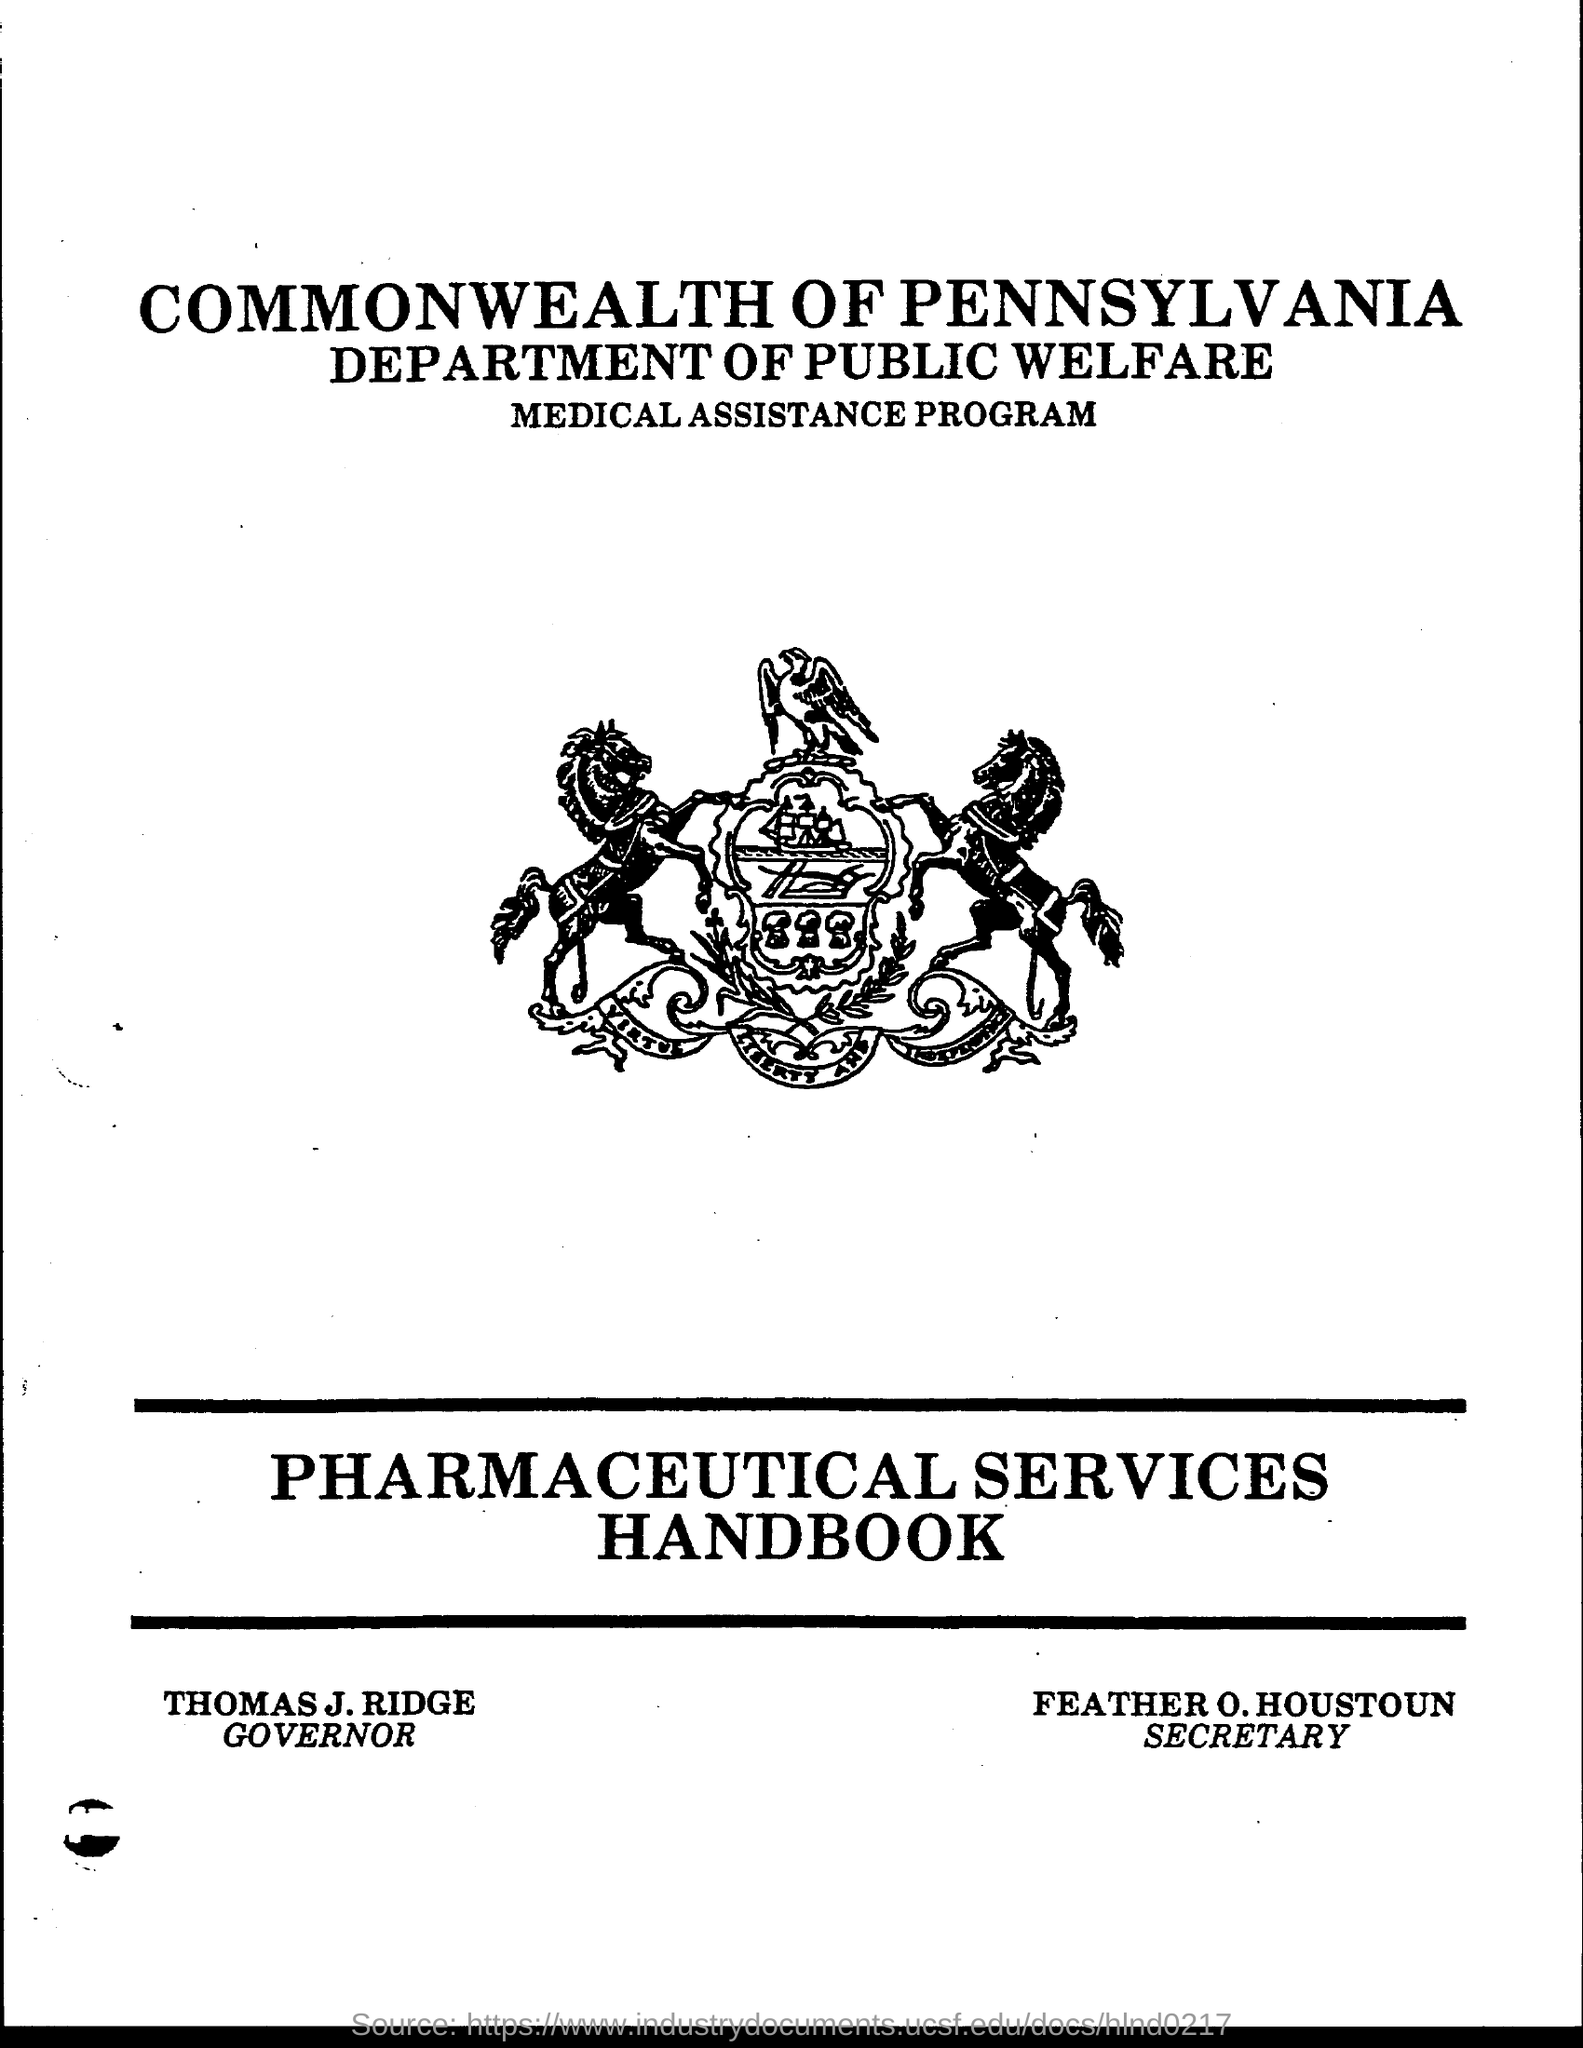List a handful of essential elements in this visual. Thomas J. Ridge is the Governor. Feather O. Houston is the Secretary. 